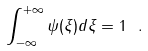Convert formula to latex. <formula><loc_0><loc_0><loc_500><loc_500>\int _ { - \infty } ^ { + \infty } \psi ( \xi ) d \xi = 1 \ .</formula> 